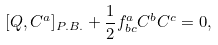<formula> <loc_0><loc_0><loc_500><loc_500>[ Q , C ^ { a } ] _ { P . B . } + \frac { 1 } { 2 } f _ { b c } ^ { a } C ^ { b } C ^ { c } = 0 ,</formula> 